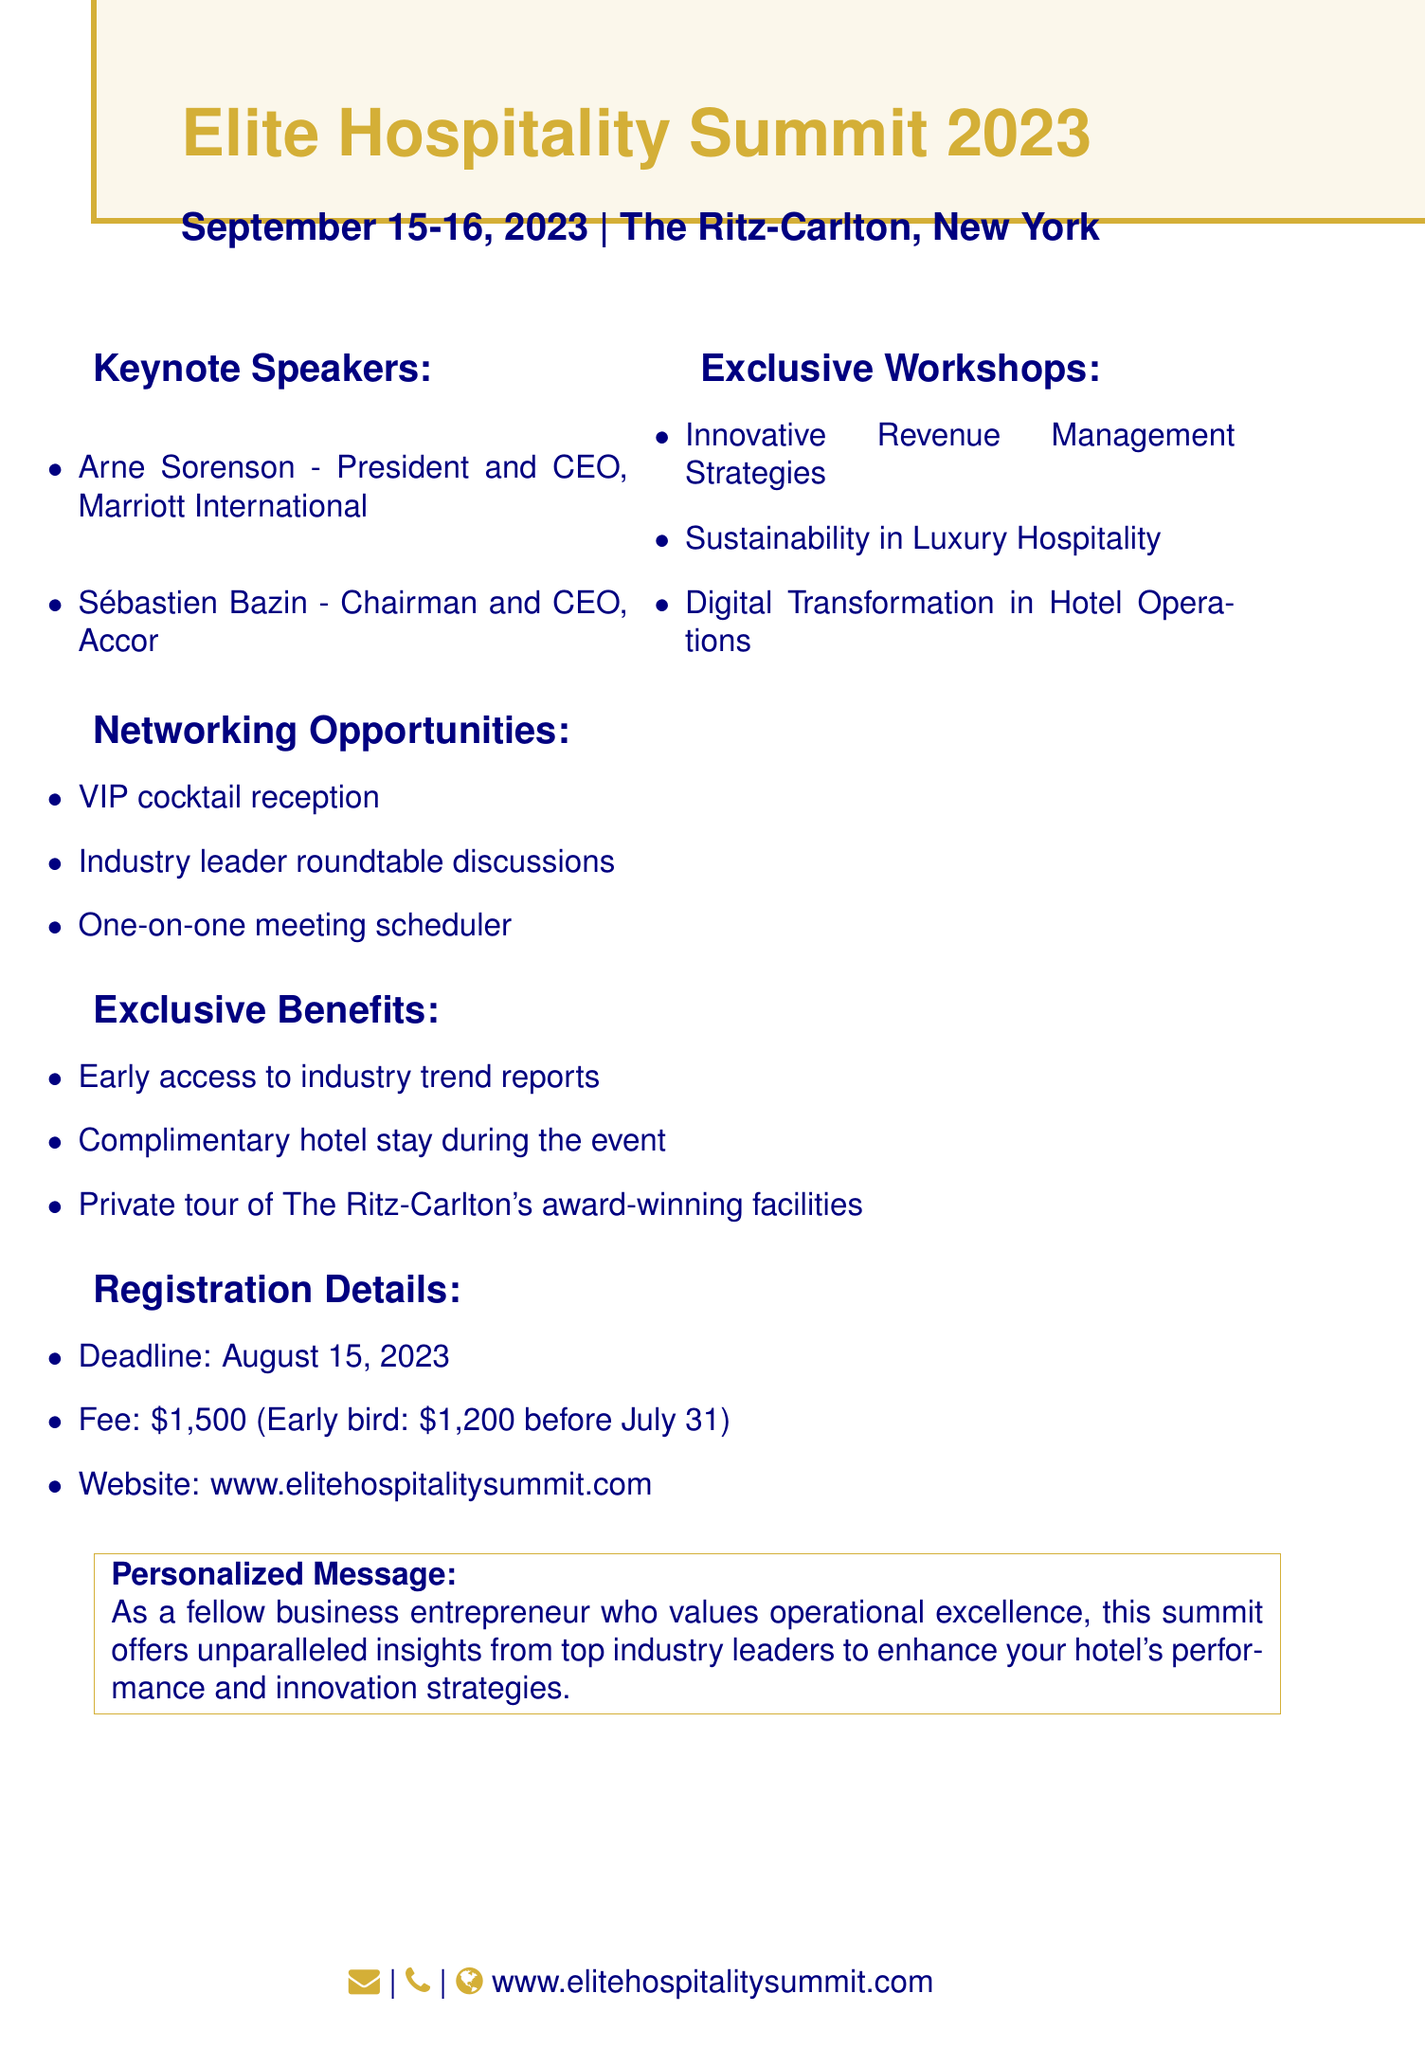What is the event name? The event name is prominently mentioned as the main title in the document.
Answer: Elite Hospitality Summit 2023 What are the dates of the event? The dates are specified right after the event name.
Answer: September 15-16, 2023 Where is the event being held? The venue is listed directly beneath the dates.
Answer: The Ritz-Carlton, New York Who is one of the keynote speakers? The document lists the keynote speakers in a clear format.
Answer: Arne Sorenson What is the registration deadline? The registration deadline is clearly stated under registration details.
Answer: August 15, 2023 What is the fee for early bird registration? The early bird fee is specified in the registration details section.
Answer: $1,200 before July 31 What opportunities are available for networking? The document outlines various networking opportunities available at the event.
Answer: VIP cocktail reception What is one of the exclusive benefits of attending? The exclusive benefits are listed under a distinct section in the document.
Answer: Complimentary hotel stay during the event What kind of workshops are offered at the summit? The workshops are detailed in a separate section for clarity.
Answer: Innovative Revenue Management Strategies 